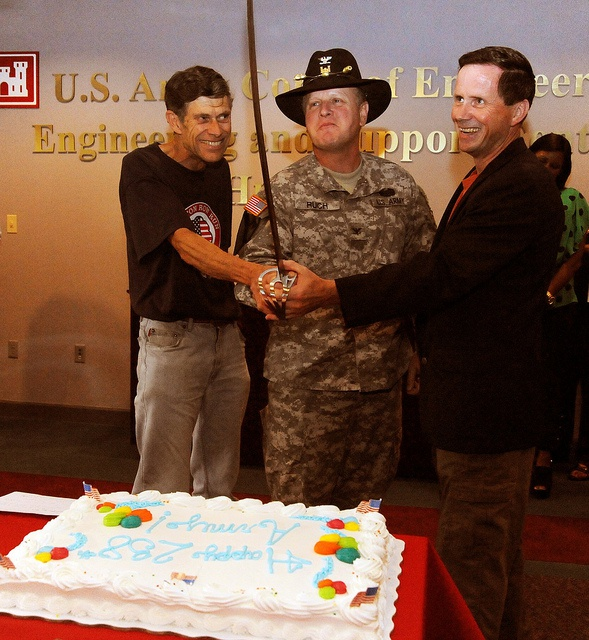Describe the objects in this image and their specific colors. I can see people in gray, black, maroon, brown, and lightpink tones, dining table in gray, ivory, brown, and tan tones, cake in gray, ivory, tan, and lightblue tones, people in gray, black, and maroon tones, and people in gray, black, maroon, and brown tones in this image. 